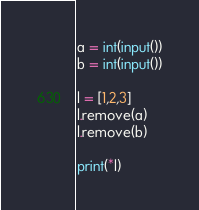Convert code to text. <code><loc_0><loc_0><loc_500><loc_500><_Python_>a = int(input())
b = int(input())

l = [1,2,3]
l.remove(a)
l.remove(b)

print(*l)</code> 